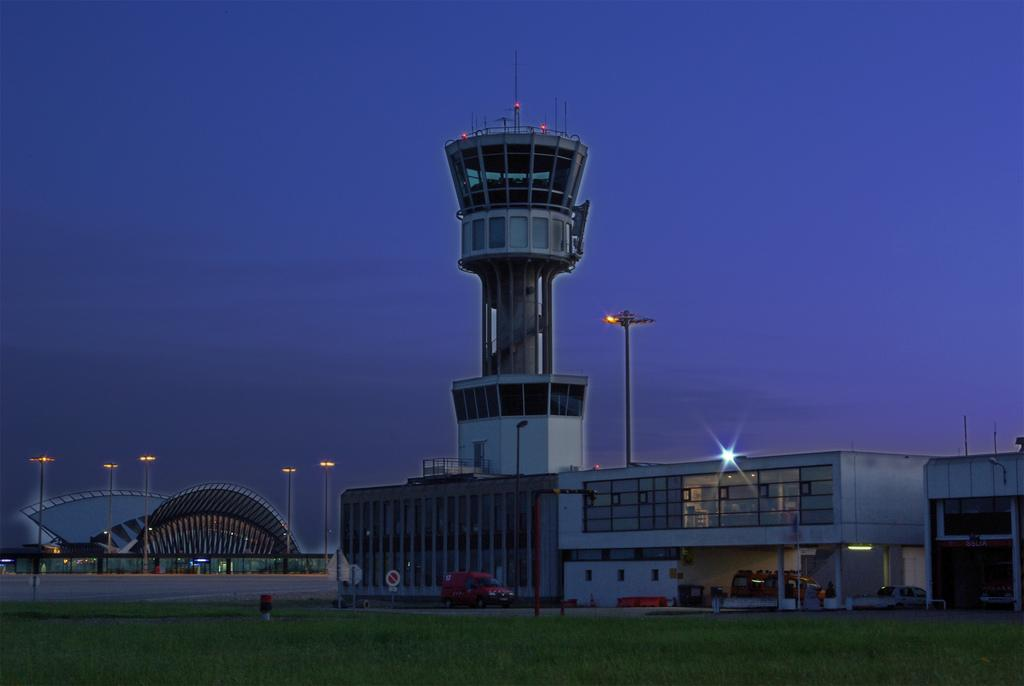What type of surface is on the ground in the image? There is grass on the ground in the image. What type of structure can be seen in the image? There is a building and a tower in the image. What mode of transportation is visible in the image? A vehicle is visible in the image. What are the tall, thin structures in the background of the image? There are poles in the background of the image. What is visible in the sky in the image? The sky is visible in the background of the image. What type of stew is being cooked in the image? There is no stew present in the image; it features grass, a building, a tower, a vehicle, poles, and the sky. What is the current temperature in the image? The image does not provide information about the temperature; it only shows the visual elements mentioned. 